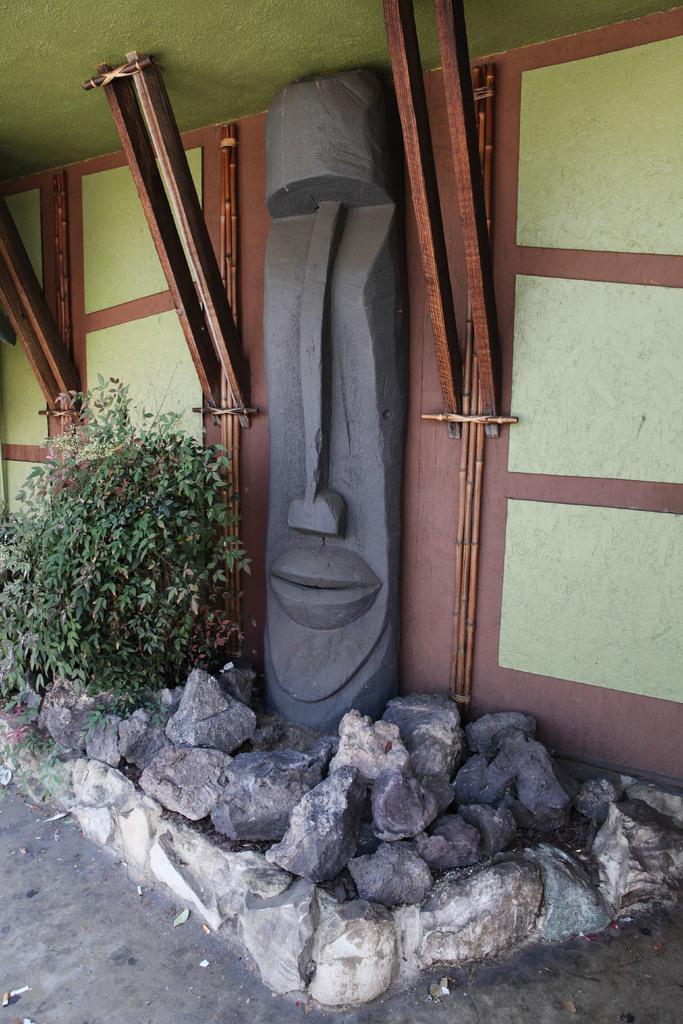Please provide a concise description of this image. In the center of the image there is a wall and we can see a sculpture on the wall. At the bottom there are rocks and a plant. 